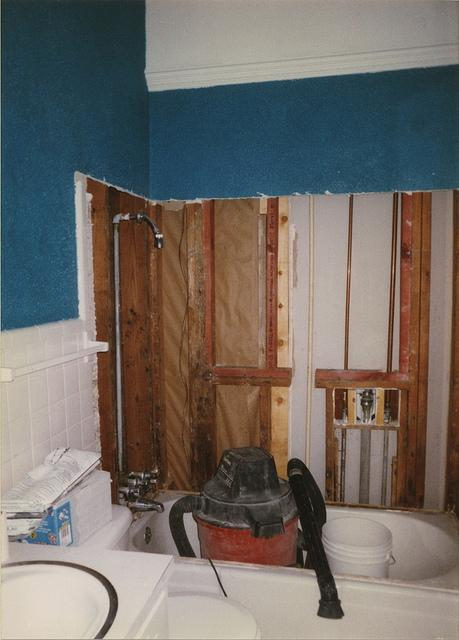Why did they open up the wall?

Choices:
A) leak
B) decoration
C) styling
D) for fun leak 